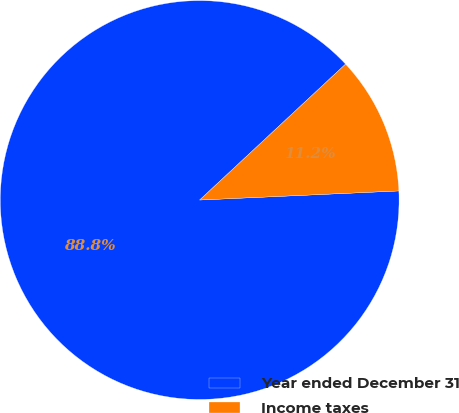<chart> <loc_0><loc_0><loc_500><loc_500><pie_chart><fcel>Year ended December 31<fcel>Income taxes<nl><fcel>88.79%<fcel>11.21%<nl></chart> 